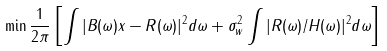Convert formula to latex. <formula><loc_0><loc_0><loc_500><loc_500>\min \frac { 1 } { 2 \pi } \left [ \int | B ( \omega ) x - R ( \omega ) | ^ { 2 } d \omega + { \sigma _ { w } ^ { 2 } } \int | R ( \omega ) / H ( \omega ) | ^ { 2 } d \omega \right ]</formula> 